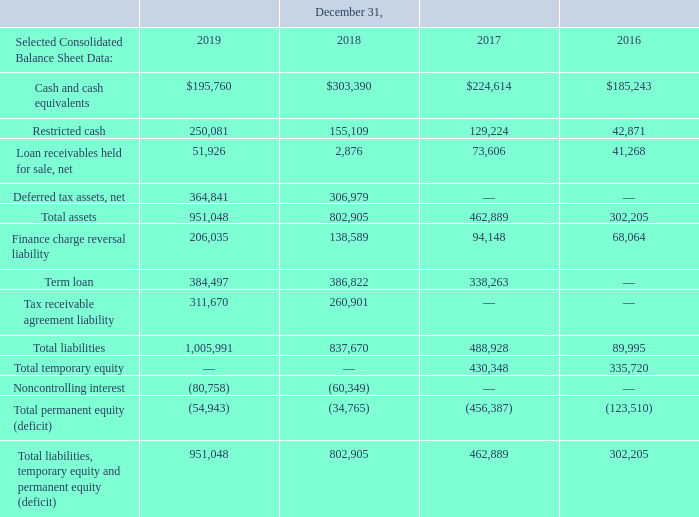ITEM 6. SELECTED FINANCIAL DATA (Dollars in thousands, except per share data and unless otherwise indicated)
The Selected Consolidated Statements of Operations Data for the years ended December 31, 2019, 2018 and 2017 and the Selected Consolidated Balance Sheet Data as of December 31, 2019 and 2018 were derived from our Consolidated Financial Statements included in Item 8 of this Form 10-K. The Selected Consolidated Statements of Operations Data for the years ended December 31, 2016 and 2015 and the Selected Consolidated Balance Sheet Data as of December 31, 2017 and 2016 were derived from our audited Consolidated Financial Statements not included in this Form 10-K. Our historical results are not necessarily indicative of the results to be expected in the future. You should read the following financial information together with the information under Item 7 "Management's Discussion and Analysis of Financial Condition and Results of Operations" and the Consolidated Financial Statements and related notes included in Item 8.
GS Holdings and GSLLC are our predecessors for accounting purposes and, accordingly, amounts prior to the Reorganization Transactions and IPO represent the historical consolidated operations of either GS Holdings or GSLLC and its subsidiaries. The amounts as of December 31, 2019 and 2018 and during the period from May 24, 2018 through December 31, 2019 represent those of consolidated GreenSky, Inc. and its subsidiaries. Prior to the Reorganization Transactions and IPO, GreenSky, Inc. did not engage in any business or other activities except in connection with its formation and initial capitalization. See Note 1 to the Notes to Consolidated Financial Statements in Item 8 for further information on our organization.
Which years does the table provide information for the company's Selected Consolidated Balance Sheet Data? 2019, 2018, 2017, 2016. What was the amount of restricted cash in 2019?
Answer scale should be: thousand. 250,081. What was the amount of Cash and cash equivalents in 2016?
Answer scale should be: thousand. 185,243. How many years did Restricted Cash exceed $200,000 thousand? 2019
Answer: 1. What was the change in Cash and cash equivalents between 2016 and 2017?
Answer scale should be: thousand. 224,614-185,243
Answer: 39371. What was the percentage change in total assets between 2018 and 2019?
Answer scale should be: percent. (951,048-802,905)/802,905
Answer: 18.45. 